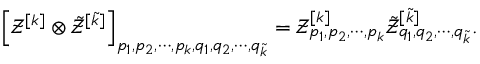<formula> <loc_0><loc_0><loc_500><loc_500>\left [ \mathcal { Z } ^ { [ k ] } \otimes \tilde { \mathcal { Z } } ^ { [ \tilde { k } ] } \right ] _ { p _ { 1 } , p _ { 2 } , \cdots , p _ { k } , q _ { 1 } , q _ { 2 } , \cdots , q _ { \tilde { k } } } = \mathcal { Z } _ { p _ { 1 } , p _ { 2 } , \cdots , p _ { k } } ^ { [ k ] } \tilde { \mathcal { Z } } _ { q _ { 1 } , q _ { 2 } , \cdots , q _ { \tilde { k } } } ^ { [ \tilde { k } ] } .</formula> 